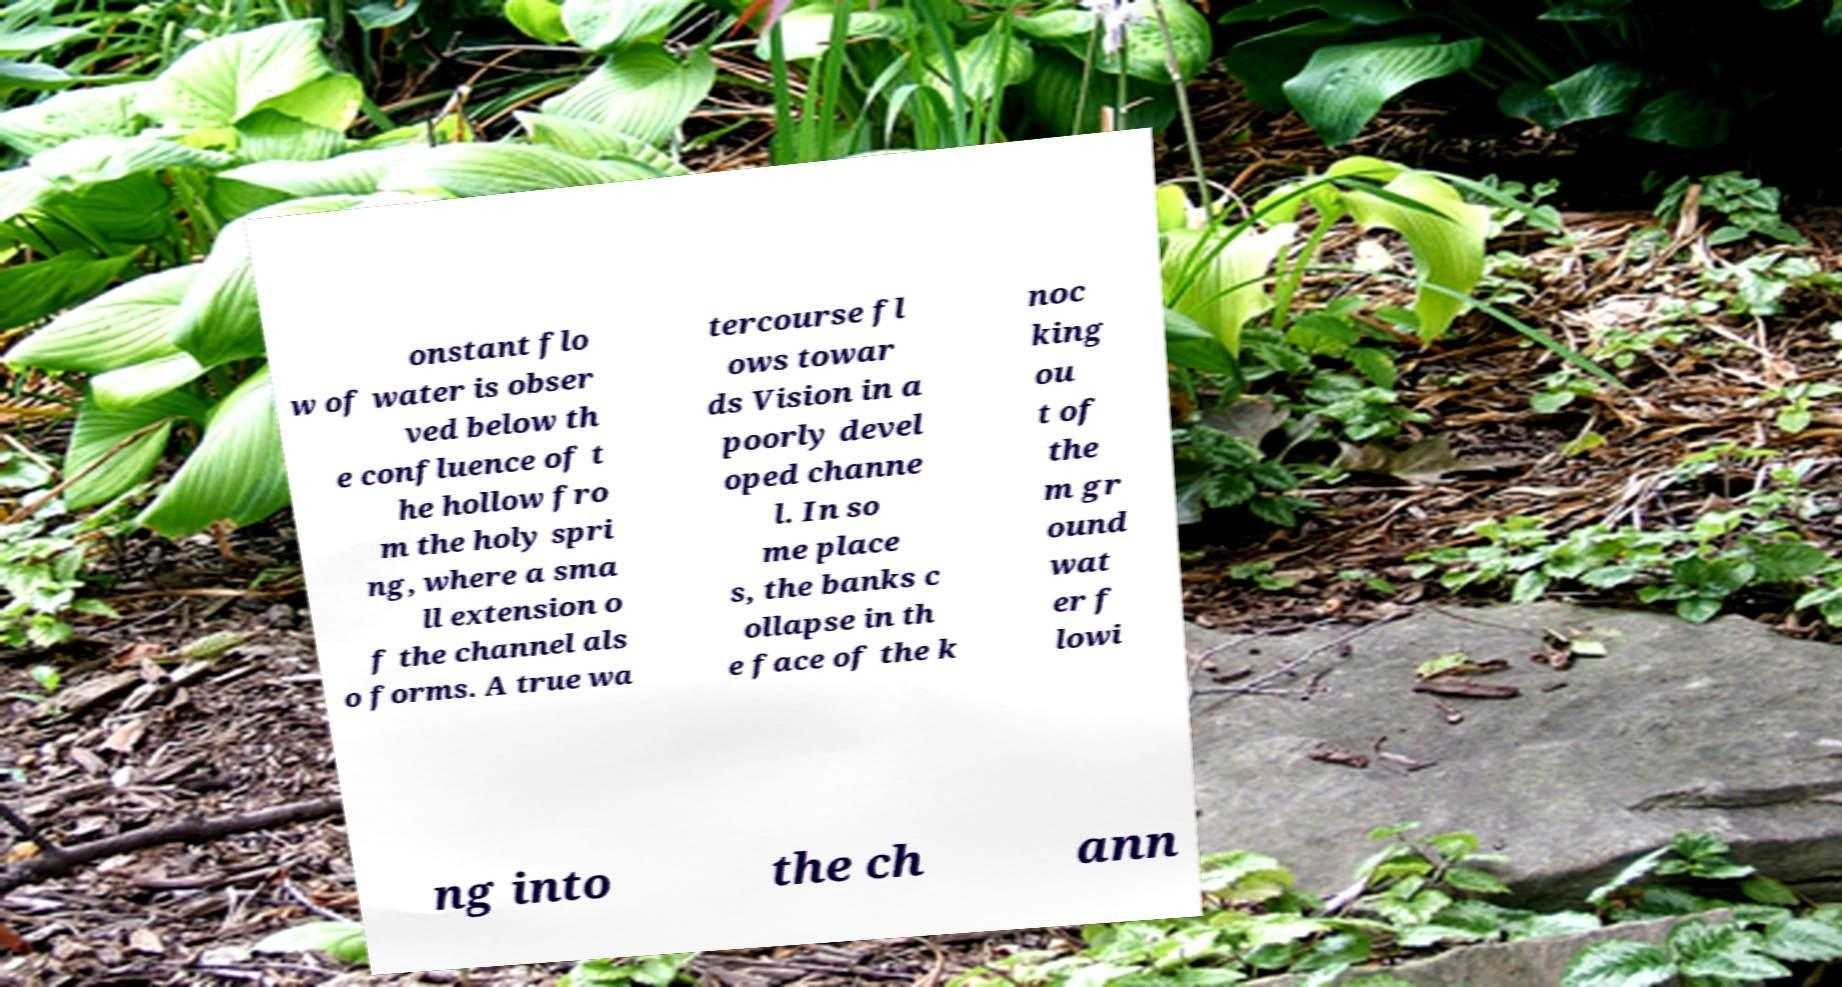Please identify and transcribe the text found in this image. onstant flo w of water is obser ved below th e confluence of t he hollow fro m the holy spri ng, where a sma ll extension o f the channel als o forms. A true wa tercourse fl ows towar ds Vision in a poorly devel oped channe l. In so me place s, the banks c ollapse in th e face of the k noc king ou t of the m gr ound wat er f lowi ng into the ch ann 